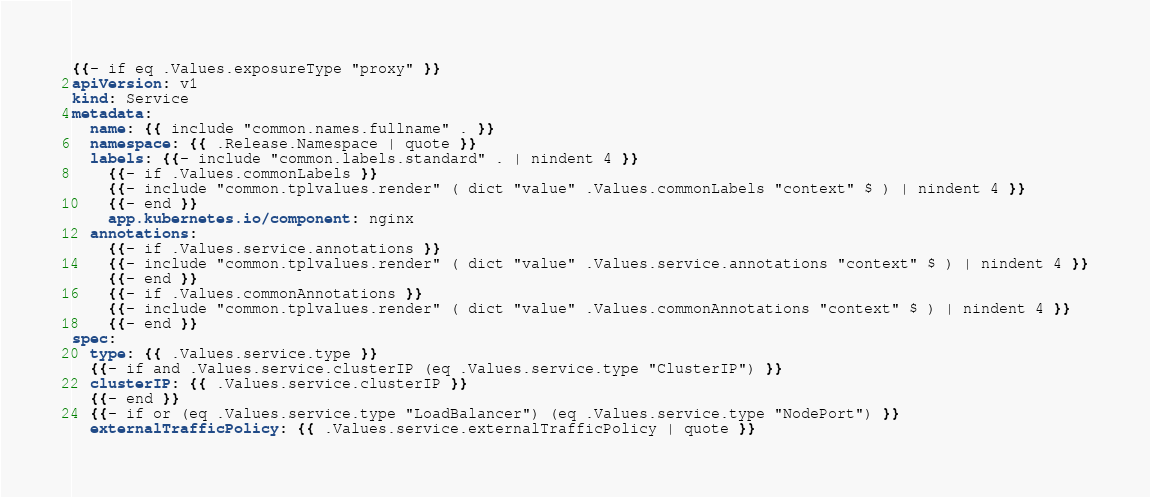Convert code to text. <code><loc_0><loc_0><loc_500><loc_500><_YAML_>{{- if eq .Values.exposureType "proxy" }}
apiVersion: v1
kind: Service
metadata:
  name: {{ include "common.names.fullname" . }}
  namespace: {{ .Release.Namespace | quote }}
  labels: {{- include "common.labels.standard" . | nindent 4 }}
    {{- if .Values.commonLabels }}
    {{- include "common.tplvalues.render" ( dict "value" .Values.commonLabels "context" $ ) | nindent 4 }}
    {{- end }}
    app.kubernetes.io/component: nginx
  annotations:
    {{- if .Values.service.annotations }}
    {{- include "common.tplvalues.render" ( dict "value" .Values.service.annotations "context" $ ) | nindent 4 }}
    {{- end }}
    {{- if .Values.commonAnnotations }}
    {{- include "common.tplvalues.render" ( dict "value" .Values.commonAnnotations "context" $ ) | nindent 4 }}
    {{- end }}
spec:
  type: {{ .Values.service.type }}
  {{- if and .Values.service.clusterIP (eq .Values.service.type "ClusterIP") }}
  clusterIP: {{ .Values.service.clusterIP }}
  {{- end }}
  {{- if or (eq .Values.service.type "LoadBalancer") (eq .Values.service.type "NodePort") }}
  externalTrafficPolicy: {{ .Values.service.externalTrafficPolicy | quote }}</code> 